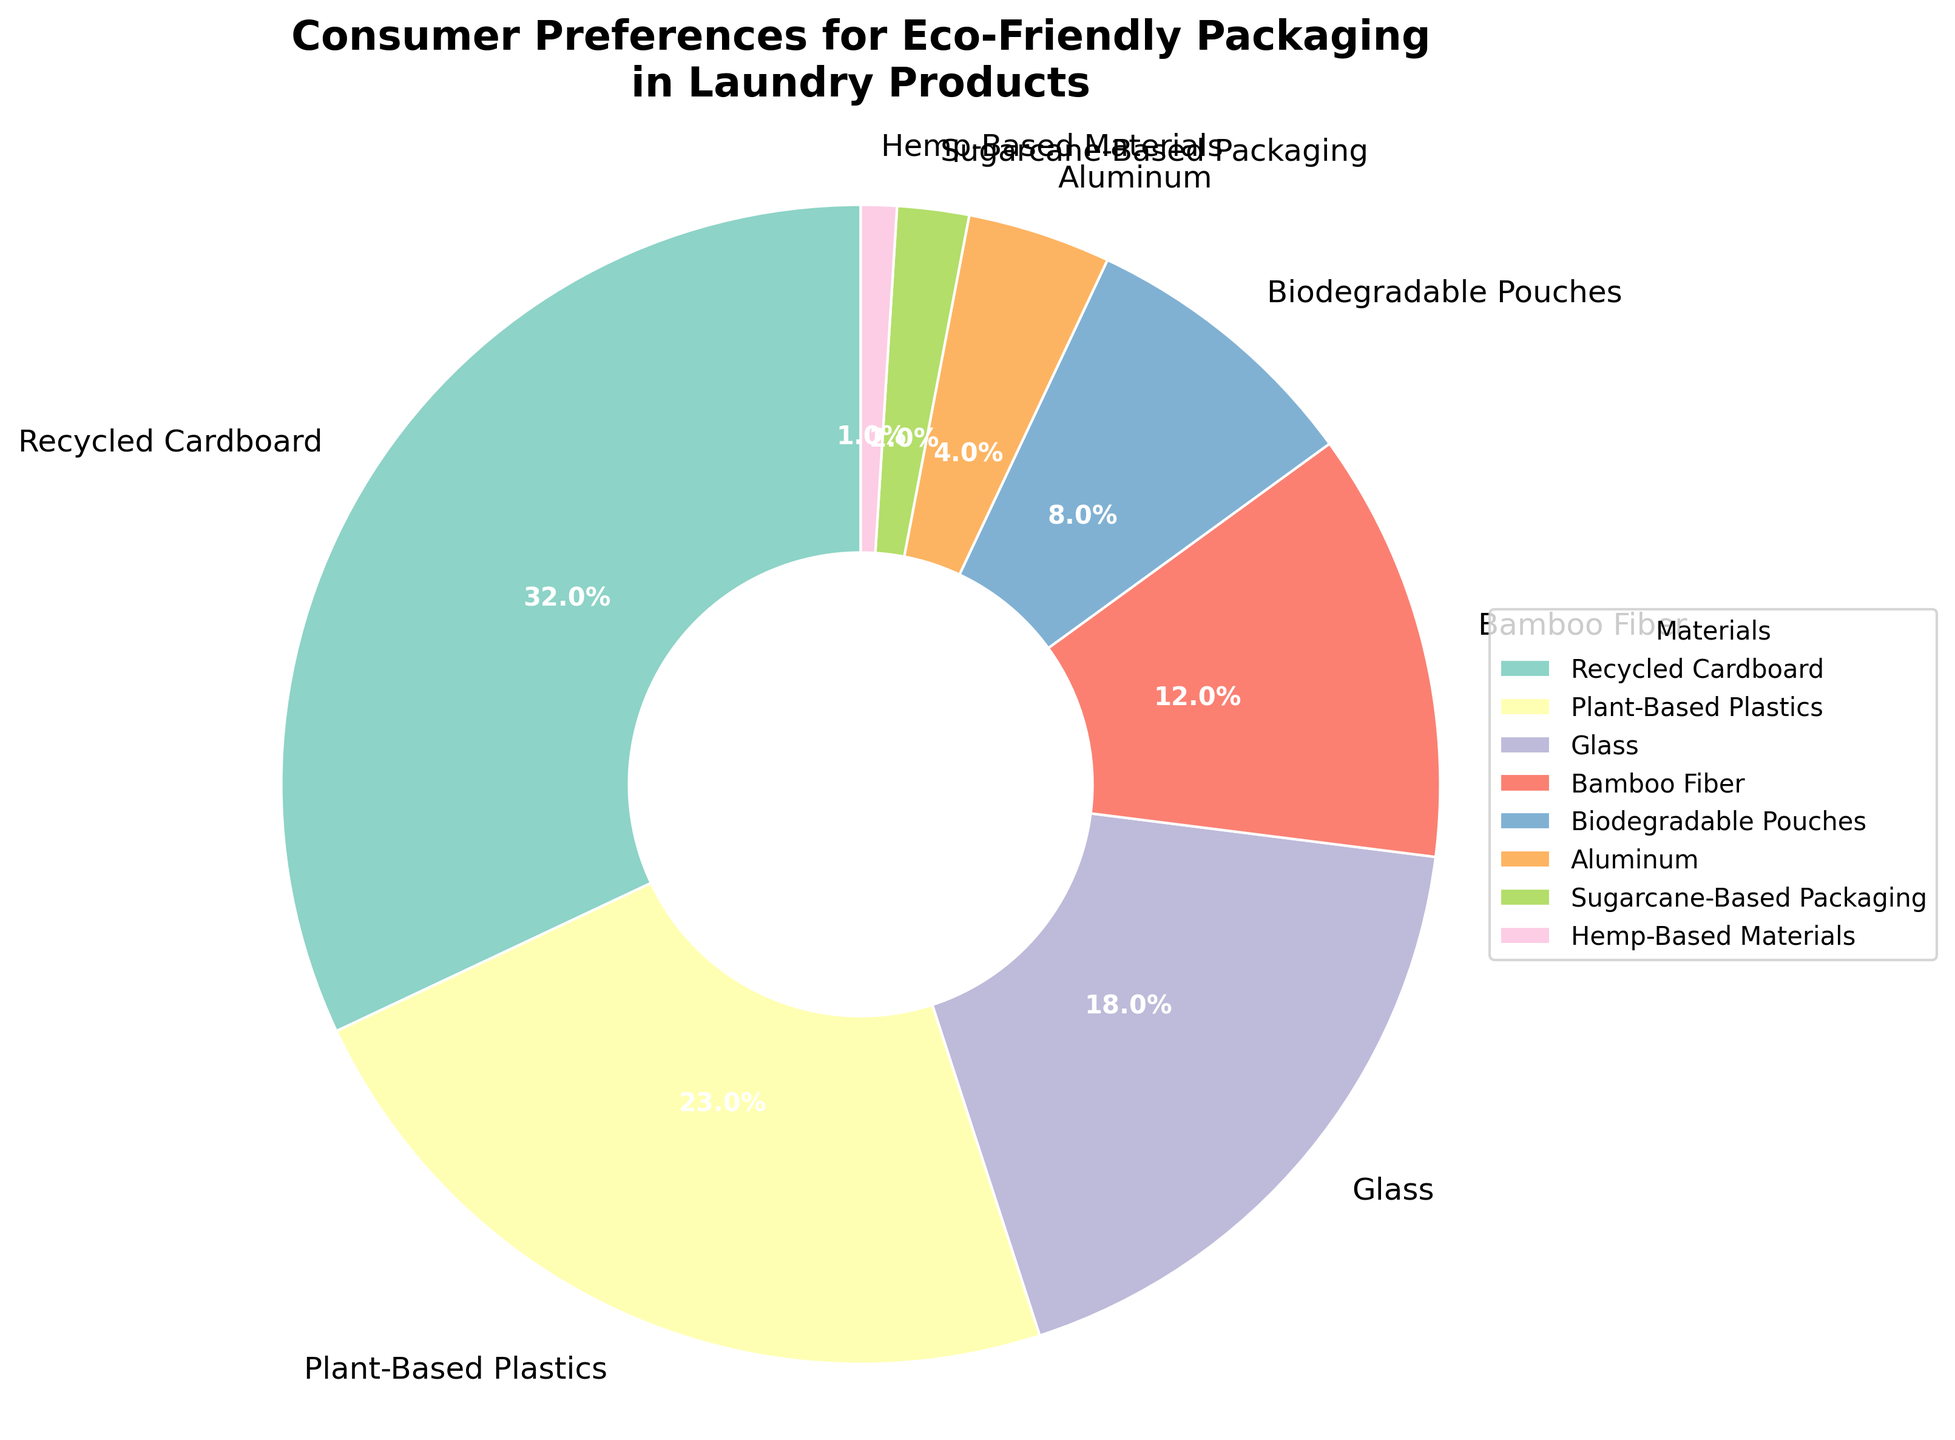Consumer preferences for eco-friendly packaging materials in laundry products The highest preference is given to recycled cardboard, which has the largest slice in the pie chart. The numeric value is 32%.
Answer: Recycled Cardboard 32% Which two materials together constitute less than 5% of consumer preference? By examining the percentages of each material, only Sugarcane-Based Packaging (2%) and Hemp-Based Materials (1%) fit this criterion. Their sum is 2% + 1% = 3%.
Answer: Sugarcane-Based Packaging and Hemp-Based Materials Which material is preferred by consumers by a margin of more than 10% over bamboo fiber? Bamboo Fiber has a preference of 12%. The only materials with more than a 10% higher preference are Recycled Cardboard (32%) and Plant-Based Plastics (23%).
Answer: Recycled Cardboard and Plant-Based Plastics What is the combined percentage preference for glass and bamboo fiber? The preference for Glass is 18%, and for Bamboo Fiber is 12%. Adding these together gives 18% + 12% = 30%.
Answer: 30% Which material is less preferred than plant-based plastics but more preferred than biodegradable pouches? Plant-Based Plastics are preferred by 23%, and Biodegradable Pouches by 8%. The material that falls between these is Glass at 18%.
Answer: Glass What is the least preferred material among the options listed? The smallest slice on the pie chart represents Hemp-Based Materials with a percentage of 1%, making it the least preferred.
Answer: Hemp-Based Materials If we consider the top three preferred materials, what percentage of consumer preference do they collectively represent? Adding the percentages of the top three: Recycled Cardboard (32%), Plant-Based Plastics (23%), and Glass (18%) yields 32% + 23% + 18% = 73%.
Answer: 73% How much more preferred are plant-based plastics compared to aluminum packaging? Plant-Based Plastics are preferred by 23%, while Aluminum is preferred by 4%. The difference is 23% - 4% = 19%.
Answer: 19% What is the percentage difference between the most and the least preferred packaging materials? The most preferred material is Recycled Cardboard at 32%, and the least preferred is Hemp-Based Materials at 1%. The difference is 32% - 1% = 31%.
Answer: 31% Between glass and bamboo fiber, which material do consumers prefer more and by what percentage? Glass is preferred by 18%, while Bamboo Fiber is preferred by 12%. The difference is 18% - 12% = 6%.
Answer: Glass by 6% 